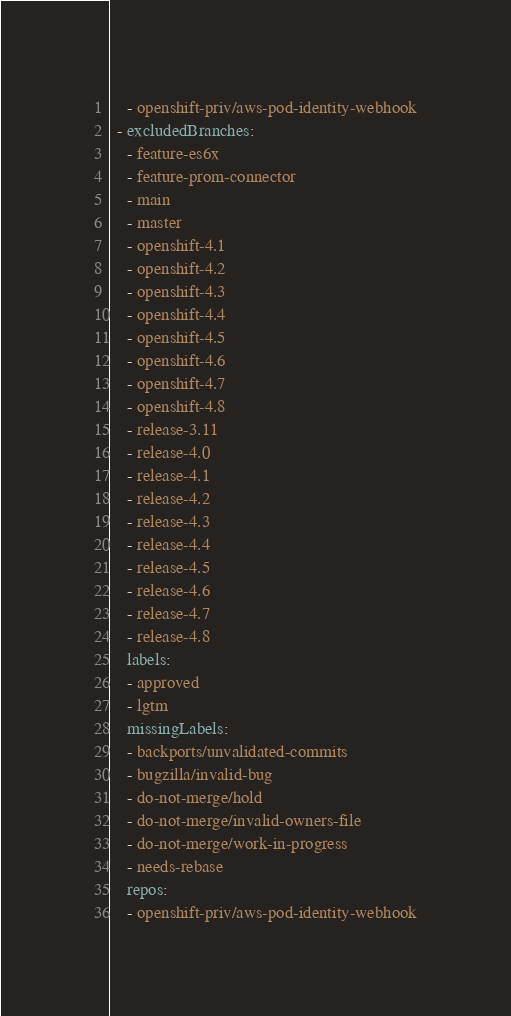Convert code to text. <code><loc_0><loc_0><loc_500><loc_500><_YAML_>    - openshift-priv/aws-pod-identity-webhook
  - excludedBranches:
    - feature-es6x
    - feature-prom-connector
    - main
    - master
    - openshift-4.1
    - openshift-4.2
    - openshift-4.3
    - openshift-4.4
    - openshift-4.5
    - openshift-4.6
    - openshift-4.7
    - openshift-4.8
    - release-3.11
    - release-4.0
    - release-4.1
    - release-4.2
    - release-4.3
    - release-4.4
    - release-4.5
    - release-4.6
    - release-4.7
    - release-4.8
    labels:
    - approved
    - lgtm
    missingLabels:
    - backports/unvalidated-commits
    - bugzilla/invalid-bug
    - do-not-merge/hold
    - do-not-merge/invalid-owners-file
    - do-not-merge/work-in-progress
    - needs-rebase
    repos:
    - openshift-priv/aws-pod-identity-webhook
</code> 